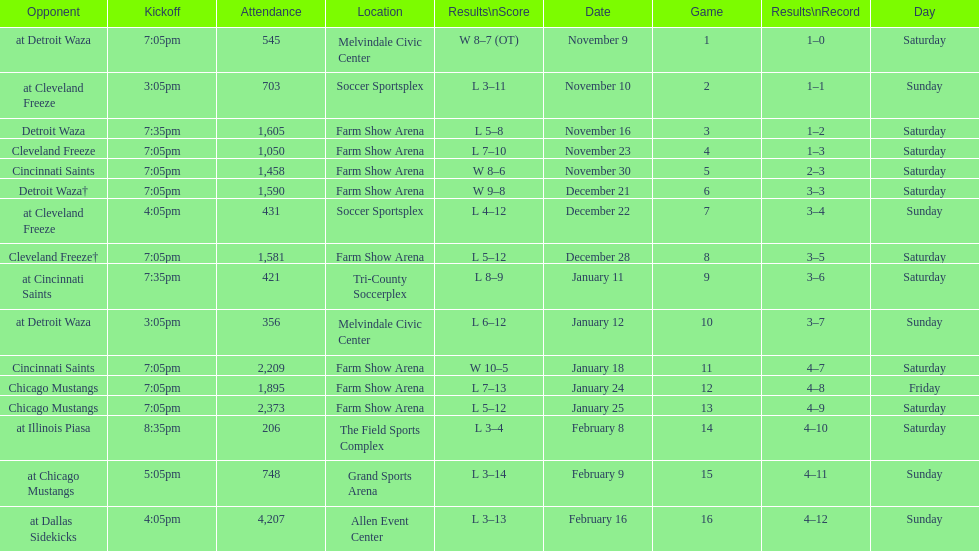Which opponent is listed first in the table? Detroit Waza. 